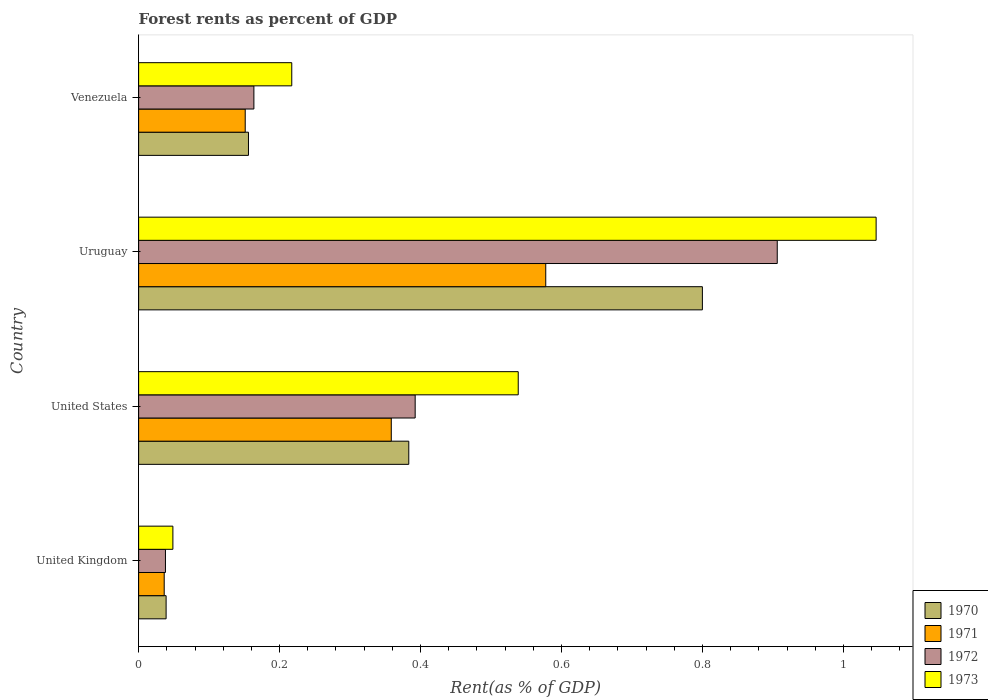How many groups of bars are there?
Provide a succinct answer. 4. Are the number of bars on each tick of the Y-axis equal?
Keep it short and to the point. Yes. What is the label of the 3rd group of bars from the top?
Give a very brief answer. United States. What is the forest rent in 1972 in Venezuela?
Your answer should be very brief. 0.16. Across all countries, what is the maximum forest rent in 1970?
Give a very brief answer. 0.8. Across all countries, what is the minimum forest rent in 1972?
Provide a succinct answer. 0.04. In which country was the forest rent in 1973 maximum?
Your response must be concise. Uruguay. What is the total forest rent in 1970 in the graph?
Your answer should be compact. 1.38. What is the difference between the forest rent in 1972 in United States and that in Uruguay?
Make the answer very short. -0.51. What is the difference between the forest rent in 1973 in Venezuela and the forest rent in 1971 in United States?
Ensure brevity in your answer.  -0.14. What is the average forest rent in 1972 per country?
Provide a succinct answer. 0.38. What is the difference between the forest rent in 1972 and forest rent in 1970 in United States?
Your answer should be compact. 0.01. What is the ratio of the forest rent in 1971 in Uruguay to that in Venezuela?
Your answer should be compact. 3.82. Is the forest rent in 1971 in United Kingdom less than that in Uruguay?
Keep it short and to the point. Yes. Is the difference between the forest rent in 1972 in Uruguay and Venezuela greater than the difference between the forest rent in 1970 in Uruguay and Venezuela?
Give a very brief answer. Yes. What is the difference between the highest and the second highest forest rent in 1972?
Make the answer very short. 0.51. What is the difference between the highest and the lowest forest rent in 1971?
Make the answer very short. 0.54. In how many countries, is the forest rent in 1972 greater than the average forest rent in 1972 taken over all countries?
Your answer should be compact. 2. Is it the case that in every country, the sum of the forest rent in 1973 and forest rent in 1971 is greater than the sum of forest rent in 1972 and forest rent in 1970?
Make the answer very short. No. What does the 3rd bar from the top in Uruguay represents?
Make the answer very short. 1971. What does the 4th bar from the bottom in Venezuela represents?
Provide a succinct answer. 1973. Are all the bars in the graph horizontal?
Offer a very short reply. Yes. How many countries are there in the graph?
Keep it short and to the point. 4. Are the values on the major ticks of X-axis written in scientific E-notation?
Give a very brief answer. No. Does the graph contain any zero values?
Give a very brief answer. No. How many legend labels are there?
Your answer should be very brief. 4. How are the legend labels stacked?
Your response must be concise. Vertical. What is the title of the graph?
Make the answer very short. Forest rents as percent of GDP. Does "1987" appear as one of the legend labels in the graph?
Keep it short and to the point. No. What is the label or title of the X-axis?
Give a very brief answer. Rent(as % of GDP). What is the label or title of the Y-axis?
Make the answer very short. Country. What is the Rent(as % of GDP) of 1970 in United Kingdom?
Ensure brevity in your answer.  0.04. What is the Rent(as % of GDP) of 1971 in United Kingdom?
Make the answer very short. 0.04. What is the Rent(as % of GDP) of 1972 in United Kingdom?
Make the answer very short. 0.04. What is the Rent(as % of GDP) in 1973 in United Kingdom?
Your answer should be compact. 0.05. What is the Rent(as % of GDP) in 1970 in United States?
Your answer should be compact. 0.38. What is the Rent(as % of GDP) of 1971 in United States?
Ensure brevity in your answer.  0.36. What is the Rent(as % of GDP) of 1972 in United States?
Offer a terse response. 0.39. What is the Rent(as % of GDP) of 1973 in United States?
Keep it short and to the point. 0.54. What is the Rent(as % of GDP) of 1970 in Uruguay?
Make the answer very short. 0.8. What is the Rent(as % of GDP) in 1971 in Uruguay?
Offer a terse response. 0.58. What is the Rent(as % of GDP) of 1972 in Uruguay?
Keep it short and to the point. 0.91. What is the Rent(as % of GDP) in 1973 in Uruguay?
Provide a short and direct response. 1.05. What is the Rent(as % of GDP) in 1970 in Venezuela?
Provide a short and direct response. 0.16. What is the Rent(as % of GDP) of 1971 in Venezuela?
Your answer should be compact. 0.15. What is the Rent(as % of GDP) in 1972 in Venezuela?
Offer a very short reply. 0.16. What is the Rent(as % of GDP) of 1973 in Venezuela?
Your response must be concise. 0.22. Across all countries, what is the maximum Rent(as % of GDP) in 1970?
Provide a short and direct response. 0.8. Across all countries, what is the maximum Rent(as % of GDP) of 1971?
Provide a succinct answer. 0.58. Across all countries, what is the maximum Rent(as % of GDP) in 1972?
Provide a succinct answer. 0.91. Across all countries, what is the maximum Rent(as % of GDP) of 1973?
Keep it short and to the point. 1.05. Across all countries, what is the minimum Rent(as % of GDP) in 1970?
Give a very brief answer. 0.04. Across all countries, what is the minimum Rent(as % of GDP) of 1971?
Give a very brief answer. 0.04. Across all countries, what is the minimum Rent(as % of GDP) of 1972?
Provide a short and direct response. 0.04. Across all countries, what is the minimum Rent(as % of GDP) of 1973?
Provide a short and direct response. 0.05. What is the total Rent(as % of GDP) in 1970 in the graph?
Provide a succinct answer. 1.38. What is the total Rent(as % of GDP) in 1971 in the graph?
Keep it short and to the point. 1.12. What is the total Rent(as % of GDP) of 1972 in the graph?
Offer a very short reply. 1.5. What is the total Rent(as % of GDP) of 1973 in the graph?
Give a very brief answer. 1.85. What is the difference between the Rent(as % of GDP) of 1970 in United Kingdom and that in United States?
Offer a terse response. -0.34. What is the difference between the Rent(as % of GDP) in 1971 in United Kingdom and that in United States?
Provide a short and direct response. -0.32. What is the difference between the Rent(as % of GDP) in 1972 in United Kingdom and that in United States?
Ensure brevity in your answer.  -0.35. What is the difference between the Rent(as % of GDP) of 1973 in United Kingdom and that in United States?
Provide a short and direct response. -0.49. What is the difference between the Rent(as % of GDP) of 1970 in United Kingdom and that in Uruguay?
Offer a terse response. -0.76. What is the difference between the Rent(as % of GDP) of 1971 in United Kingdom and that in Uruguay?
Provide a short and direct response. -0.54. What is the difference between the Rent(as % of GDP) of 1972 in United Kingdom and that in Uruguay?
Offer a terse response. -0.87. What is the difference between the Rent(as % of GDP) of 1973 in United Kingdom and that in Uruguay?
Ensure brevity in your answer.  -1. What is the difference between the Rent(as % of GDP) in 1970 in United Kingdom and that in Venezuela?
Make the answer very short. -0.12. What is the difference between the Rent(as % of GDP) in 1971 in United Kingdom and that in Venezuela?
Ensure brevity in your answer.  -0.11. What is the difference between the Rent(as % of GDP) of 1972 in United Kingdom and that in Venezuela?
Keep it short and to the point. -0.13. What is the difference between the Rent(as % of GDP) of 1973 in United Kingdom and that in Venezuela?
Your response must be concise. -0.17. What is the difference between the Rent(as % of GDP) in 1970 in United States and that in Uruguay?
Ensure brevity in your answer.  -0.42. What is the difference between the Rent(as % of GDP) of 1971 in United States and that in Uruguay?
Keep it short and to the point. -0.22. What is the difference between the Rent(as % of GDP) of 1972 in United States and that in Uruguay?
Make the answer very short. -0.51. What is the difference between the Rent(as % of GDP) in 1973 in United States and that in Uruguay?
Ensure brevity in your answer.  -0.51. What is the difference between the Rent(as % of GDP) in 1970 in United States and that in Venezuela?
Make the answer very short. 0.23. What is the difference between the Rent(as % of GDP) in 1971 in United States and that in Venezuela?
Your response must be concise. 0.21. What is the difference between the Rent(as % of GDP) in 1972 in United States and that in Venezuela?
Keep it short and to the point. 0.23. What is the difference between the Rent(as % of GDP) of 1973 in United States and that in Venezuela?
Offer a terse response. 0.32. What is the difference between the Rent(as % of GDP) in 1970 in Uruguay and that in Venezuela?
Ensure brevity in your answer.  0.64. What is the difference between the Rent(as % of GDP) in 1971 in Uruguay and that in Venezuela?
Give a very brief answer. 0.43. What is the difference between the Rent(as % of GDP) of 1972 in Uruguay and that in Venezuela?
Ensure brevity in your answer.  0.74. What is the difference between the Rent(as % of GDP) in 1973 in Uruguay and that in Venezuela?
Provide a short and direct response. 0.83. What is the difference between the Rent(as % of GDP) in 1970 in United Kingdom and the Rent(as % of GDP) in 1971 in United States?
Keep it short and to the point. -0.32. What is the difference between the Rent(as % of GDP) of 1970 in United Kingdom and the Rent(as % of GDP) of 1972 in United States?
Give a very brief answer. -0.35. What is the difference between the Rent(as % of GDP) in 1970 in United Kingdom and the Rent(as % of GDP) in 1973 in United States?
Your answer should be compact. -0.5. What is the difference between the Rent(as % of GDP) in 1971 in United Kingdom and the Rent(as % of GDP) in 1972 in United States?
Your response must be concise. -0.36. What is the difference between the Rent(as % of GDP) of 1971 in United Kingdom and the Rent(as % of GDP) of 1973 in United States?
Offer a very short reply. -0.5. What is the difference between the Rent(as % of GDP) of 1972 in United Kingdom and the Rent(as % of GDP) of 1973 in United States?
Ensure brevity in your answer.  -0.5. What is the difference between the Rent(as % of GDP) of 1970 in United Kingdom and the Rent(as % of GDP) of 1971 in Uruguay?
Your answer should be compact. -0.54. What is the difference between the Rent(as % of GDP) in 1970 in United Kingdom and the Rent(as % of GDP) in 1972 in Uruguay?
Provide a succinct answer. -0.87. What is the difference between the Rent(as % of GDP) of 1970 in United Kingdom and the Rent(as % of GDP) of 1973 in Uruguay?
Provide a short and direct response. -1.01. What is the difference between the Rent(as % of GDP) of 1971 in United Kingdom and the Rent(as % of GDP) of 1972 in Uruguay?
Offer a terse response. -0.87. What is the difference between the Rent(as % of GDP) of 1971 in United Kingdom and the Rent(as % of GDP) of 1973 in Uruguay?
Your response must be concise. -1.01. What is the difference between the Rent(as % of GDP) of 1972 in United Kingdom and the Rent(as % of GDP) of 1973 in Uruguay?
Ensure brevity in your answer.  -1.01. What is the difference between the Rent(as % of GDP) of 1970 in United Kingdom and the Rent(as % of GDP) of 1971 in Venezuela?
Provide a short and direct response. -0.11. What is the difference between the Rent(as % of GDP) of 1970 in United Kingdom and the Rent(as % of GDP) of 1972 in Venezuela?
Your answer should be very brief. -0.12. What is the difference between the Rent(as % of GDP) of 1970 in United Kingdom and the Rent(as % of GDP) of 1973 in Venezuela?
Provide a short and direct response. -0.18. What is the difference between the Rent(as % of GDP) in 1971 in United Kingdom and the Rent(as % of GDP) in 1972 in Venezuela?
Give a very brief answer. -0.13. What is the difference between the Rent(as % of GDP) of 1971 in United Kingdom and the Rent(as % of GDP) of 1973 in Venezuela?
Make the answer very short. -0.18. What is the difference between the Rent(as % of GDP) in 1972 in United Kingdom and the Rent(as % of GDP) in 1973 in Venezuela?
Offer a terse response. -0.18. What is the difference between the Rent(as % of GDP) of 1970 in United States and the Rent(as % of GDP) of 1971 in Uruguay?
Your answer should be very brief. -0.19. What is the difference between the Rent(as % of GDP) of 1970 in United States and the Rent(as % of GDP) of 1972 in Uruguay?
Provide a succinct answer. -0.52. What is the difference between the Rent(as % of GDP) of 1970 in United States and the Rent(as % of GDP) of 1973 in Uruguay?
Offer a terse response. -0.66. What is the difference between the Rent(as % of GDP) in 1971 in United States and the Rent(as % of GDP) in 1972 in Uruguay?
Offer a terse response. -0.55. What is the difference between the Rent(as % of GDP) of 1971 in United States and the Rent(as % of GDP) of 1973 in Uruguay?
Ensure brevity in your answer.  -0.69. What is the difference between the Rent(as % of GDP) in 1972 in United States and the Rent(as % of GDP) in 1973 in Uruguay?
Provide a succinct answer. -0.65. What is the difference between the Rent(as % of GDP) of 1970 in United States and the Rent(as % of GDP) of 1971 in Venezuela?
Give a very brief answer. 0.23. What is the difference between the Rent(as % of GDP) of 1970 in United States and the Rent(as % of GDP) of 1972 in Venezuela?
Offer a terse response. 0.22. What is the difference between the Rent(as % of GDP) in 1970 in United States and the Rent(as % of GDP) in 1973 in Venezuela?
Give a very brief answer. 0.17. What is the difference between the Rent(as % of GDP) in 1971 in United States and the Rent(as % of GDP) in 1972 in Venezuela?
Give a very brief answer. 0.2. What is the difference between the Rent(as % of GDP) of 1971 in United States and the Rent(as % of GDP) of 1973 in Venezuela?
Provide a succinct answer. 0.14. What is the difference between the Rent(as % of GDP) in 1972 in United States and the Rent(as % of GDP) in 1973 in Venezuela?
Keep it short and to the point. 0.18. What is the difference between the Rent(as % of GDP) in 1970 in Uruguay and the Rent(as % of GDP) in 1971 in Venezuela?
Give a very brief answer. 0.65. What is the difference between the Rent(as % of GDP) in 1970 in Uruguay and the Rent(as % of GDP) in 1972 in Venezuela?
Provide a short and direct response. 0.64. What is the difference between the Rent(as % of GDP) in 1970 in Uruguay and the Rent(as % of GDP) in 1973 in Venezuela?
Your response must be concise. 0.58. What is the difference between the Rent(as % of GDP) in 1971 in Uruguay and the Rent(as % of GDP) in 1972 in Venezuela?
Your answer should be compact. 0.41. What is the difference between the Rent(as % of GDP) of 1971 in Uruguay and the Rent(as % of GDP) of 1973 in Venezuela?
Keep it short and to the point. 0.36. What is the difference between the Rent(as % of GDP) in 1972 in Uruguay and the Rent(as % of GDP) in 1973 in Venezuela?
Provide a short and direct response. 0.69. What is the average Rent(as % of GDP) of 1970 per country?
Your answer should be very brief. 0.34. What is the average Rent(as % of GDP) in 1971 per country?
Your response must be concise. 0.28. What is the average Rent(as % of GDP) in 1972 per country?
Keep it short and to the point. 0.38. What is the average Rent(as % of GDP) of 1973 per country?
Ensure brevity in your answer.  0.46. What is the difference between the Rent(as % of GDP) of 1970 and Rent(as % of GDP) of 1971 in United Kingdom?
Provide a succinct answer. 0. What is the difference between the Rent(as % of GDP) of 1970 and Rent(as % of GDP) of 1972 in United Kingdom?
Provide a succinct answer. 0. What is the difference between the Rent(as % of GDP) in 1970 and Rent(as % of GDP) in 1973 in United Kingdom?
Offer a very short reply. -0.01. What is the difference between the Rent(as % of GDP) in 1971 and Rent(as % of GDP) in 1972 in United Kingdom?
Offer a very short reply. -0. What is the difference between the Rent(as % of GDP) in 1971 and Rent(as % of GDP) in 1973 in United Kingdom?
Your answer should be very brief. -0.01. What is the difference between the Rent(as % of GDP) of 1972 and Rent(as % of GDP) of 1973 in United Kingdom?
Offer a terse response. -0.01. What is the difference between the Rent(as % of GDP) of 1970 and Rent(as % of GDP) of 1971 in United States?
Offer a terse response. 0.02. What is the difference between the Rent(as % of GDP) in 1970 and Rent(as % of GDP) in 1972 in United States?
Ensure brevity in your answer.  -0.01. What is the difference between the Rent(as % of GDP) in 1970 and Rent(as % of GDP) in 1973 in United States?
Your response must be concise. -0.16. What is the difference between the Rent(as % of GDP) of 1971 and Rent(as % of GDP) of 1972 in United States?
Give a very brief answer. -0.03. What is the difference between the Rent(as % of GDP) in 1971 and Rent(as % of GDP) in 1973 in United States?
Offer a very short reply. -0.18. What is the difference between the Rent(as % of GDP) of 1972 and Rent(as % of GDP) of 1973 in United States?
Give a very brief answer. -0.15. What is the difference between the Rent(as % of GDP) in 1970 and Rent(as % of GDP) in 1971 in Uruguay?
Your answer should be compact. 0.22. What is the difference between the Rent(as % of GDP) in 1970 and Rent(as % of GDP) in 1972 in Uruguay?
Make the answer very short. -0.11. What is the difference between the Rent(as % of GDP) in 1970 and Rent(as % of GDP) in 1973 in Uruguay?
Give a very brief answer. -0.25. What is the difference between the Rent(as % of GDP) in 1971 and Rent(as % of GDP) in 1972 in Uruguay?
Provide a short and direct response. -0.33. What is the difference between the Rent(as % of GDP) in 1971 and Rent(as % of GDP) in 1973 in Uruguay?
Keep it short and to the point. -0.47. What is the difference between the Rent(as % of GDP) of 1972 and Rent(as % of GDP) of 1973 in Uruguay?
Give a very brief answer. -0.14. What is the difference between the Rent(as % of GDP) of 1970 and Rent(as % of GDP) of 1971 in Venezuela?
Give a very brief answer. 0. What is the difference between the Rent(as % of GDP) in 1970 and Rent(as % of GDP) in 1972 in Venezuela?
Provide a short and direct response. -0.01. What is the difference between the Rent(as % of GDP) in 1970 and Rent(as % of GDP) in 1973 in Venezuela?
Ensure brevity in your answer.  -0.06. What is the difference between the Rent(as % of GDP) of 1971 and Rent(as % of GDP) of 1972 in Venezuela?
Offer a very short reply. -0.01. What is the difference between the Rent(as % of GDP) in 1971 and Rent(as % of GDP) in 1973 in Venezuela?
Keep it short and to the point. -0.07. What is the difference between the Rent(as % of GDP) in 1972 and Rent(as % of GDP) in 1973 in Venezuela?
Keep it short and to the point. -0.05. What is the ratio of the Rent(as % of GDP) in 1970 in United Kingdom to that in United States?
Offer a terse response. 0.1. What is the ratio of the Rent(as % of GDP) of 1971 in United Kingdom to that in United States?
Provide a short and direct response. 0.1. What is the ratio of the Rent(as % of GDP) in 1972 in United Kingdom to that in United States?
Give a very brief answer. 0.1. What is the ratio of the Rent(as % of GDP) of 1973 in United Kingdom to that in United States?
Keep it short and to the point. 0.09. What is the ratio of the Rent(as % of GDP) of 1970 in United Kingdom to that in Uruguay?
Offer a terse response. 0.05. What is the ratio of the Rent(as % of GDP) in 1971 in United Kingdom to that in Uruguay?
Make the answer very short. 0.06. What is the ratio of the Rent(as % of GDP) of 1972 in United Kingdom to that in Uruguay?
Your answer should be very brief. 0.04. What is the ratio of the Rent(as % of GDP) in 1973 in United Kingdom to that in Uruguay?
Your answer should be very brief. 0.05. What is the ratio of the Rent(as % of GDP) in 1970 in United Kingdom to that in Venezuela?
Make the answer very short. 0.25. What is the ratio of the Rent(as % of GDP) of 1971 in United Kingdom to that in Venezuela?
Your answer should be compact. 0.24. What is the ratio of the Rent(as % of GDP) of 1972 in United Kingdom to that in Venezuela?
Provide a short and direct response. 0.23. What is the ratio of the Rent(as % of GDP) in 1973 in United Kingdom to that in Venezuela?
Make the answer very short. 0.22. What is the ratio of the Rent(as % of GDP) in 1970 in United States to that in Uruguay?
Provide a succinct answer. 0.48. What is the ratio of the Rent(as % of GDP) in 1971 in United States to that in Uruguay?
Provide a short and direct response. 0.62. What is the ratio of the Rent(as % of GDP) of 1972 in United States to that in Uruguay?
Offer a terse response. 0.43. What is the ratio of the Rent(as % of GDP) in 1973 in United States to that in Uruguay?
Provide a short and direct response. 0.51. What is the ratio of the Rent(as % of GDP) in 1970 in United States to that in Venezuela?
Offer a terse response. 2.46. What is the ratio of the Rent(as % of GDP) in 1971 in United States to that in Venezuela?
Give a very brief answer. 2.37. What is the ratio of the Rent(as % of GDP) of 1972 in United States to that in Venezuela?
Make the answer very short. 2.4. What is the ratio of the Rent(as % of GDP) of 1973 in United States to that in Venezuela?
Provide a succinct answer. 2.48. What is the ratio of the Rent(as % of GDP) of 1970 in Uruguay to that in Venezuela?
Your answer should be compact. 5.13. What is the ratio of the Rent(as % of GDP) in 1971 in Uruguay to that in Venezuela?
Provide a succinct answer. 3.82. What is the ratio of the Rent(as % of GDP) of 1972 in Uruguay to that in Venezuela?
Provide a succinct answer. 5.54. What is the ratio of the Rent(as % of GDP) in 1973 in Uruguay to that in Venezuela?
Provide a short and direct response. 4.82. What is the difference between the highest and the second highest Rent(as % of GDP) of 1970?
Keep it short and to the point. 0.42. What is the difference between the highest and the second highest Rent(as % of GDP) of 1971?
Provide a succinct answer. 0.22. What is the difference between the highest and the second highest Rent(as % of GDP) of 1972?
Your answer should be compact. 0.51. What is the difference between the highest and the second highest Rent(as % of GDP) in 1973?
Keep it short and to the point. 0.51. What is the difference between the highest and the lowest Rent(as % of GDP) of 1970?
Your response must be concise. 0.76. What is the difference between the highest and the lowest Rent(as % of GDP) of 1971?
Keep it short and to the point. 0.54. What is the difference between the highest and the lowest Rent(as % of GDP) of 1972?
Give a very brief answer. 0.87. 